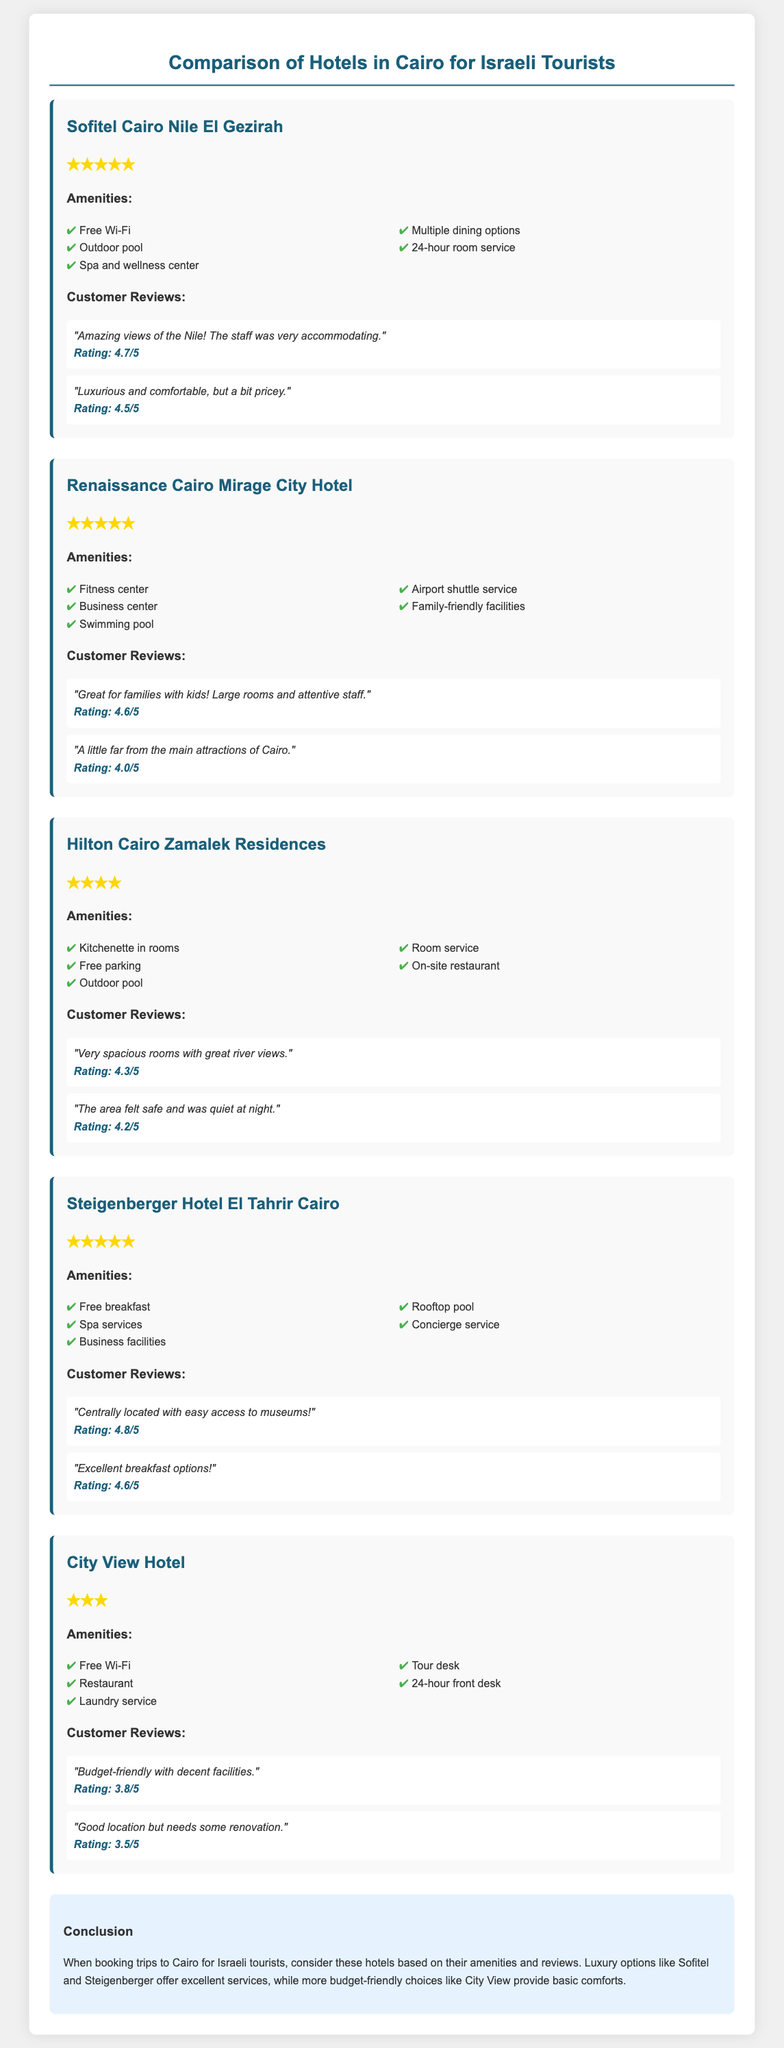What is the star rating of Sofitel Cairo Nile El Gezirah? The star rating is listed in the document and indicates the luxury level of the hotel, which is five stars.
Answer: ★★★★★ What amenities are offered at the Renaissance Cairo Mirage City Hotel? The amenities are explicitly listed in the document, which includes a fitness center and more.
Answer: Fitness center, Business center, Swimming pool, Airport shuttle service, Family-friendly facilities What is the average customer review rating for the Steigenberger Hotel El Tahrir Cairo? The ratings are provided in reviews, and the average can be derived from the two ratings listed.
Answer: 4.7/5 Which hotel has a kitchenette in rooms? The specific amenities are outlined for each hotel, and the one with kitchenettes is mentioned.
Answer: Hilton Cairo Zamalek Residences What is the conclusion regarding hotel choices for Israeli tourists? The conclusion summarizes the options based on the document's findings regarding amenities and service quality.
Answer: Consider luxury options like Sofitel and Steigenberger; budget-friendly choices like City View provide basic comforts What is the customer review of the City View Hotel regarding its budget? The document includes specific customer reviews, which express sentiments about the hotel's affordability and comfort.
Answer: Budget-friendly with decent facilities Which hotel is described as having "great river views"? This is inferred from the customer reviews listed within the hotel section.
Answer: Hilton Cairo Zamalek Residences What type of service is included at the Sofitel Cairo Nile El Gezirah? The amenities section includes types of services offered by the hotel.
Answer: Spa and wellness center 